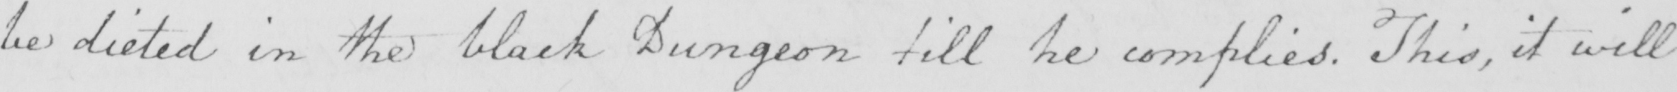Please provide the text content of this handwritten line. be dieted in the black Dungeon till he complies . This , it will 